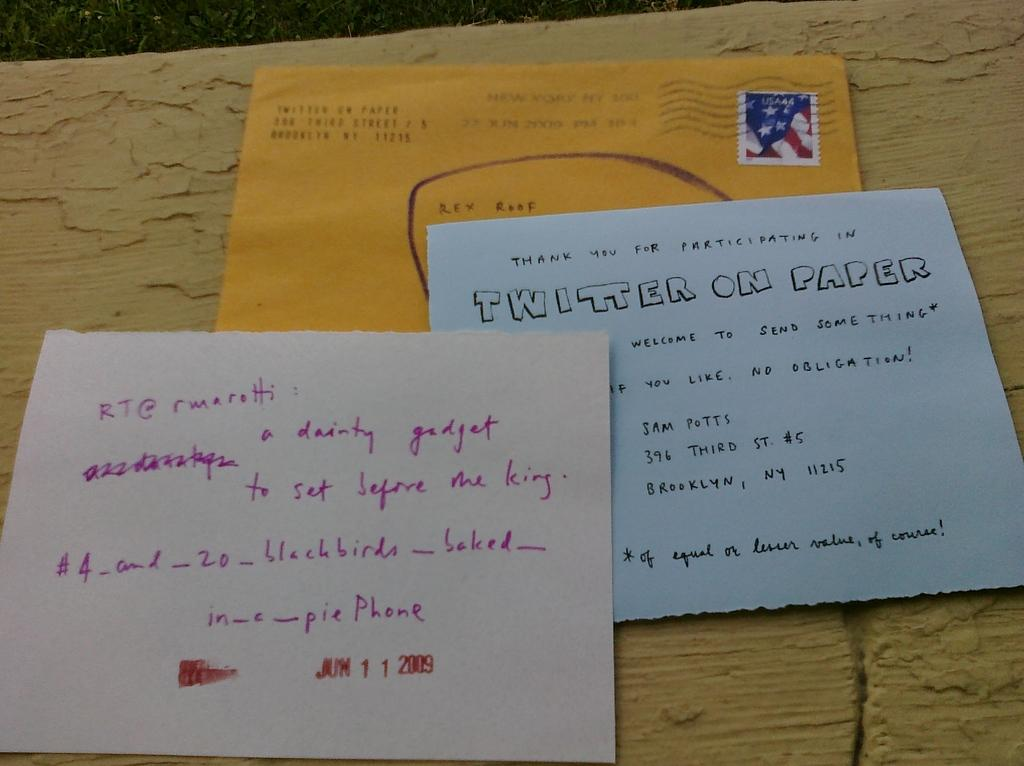<image>
Render a clear and concise summary of the photo. a yellow envelope is under two letters about twitter on paper 